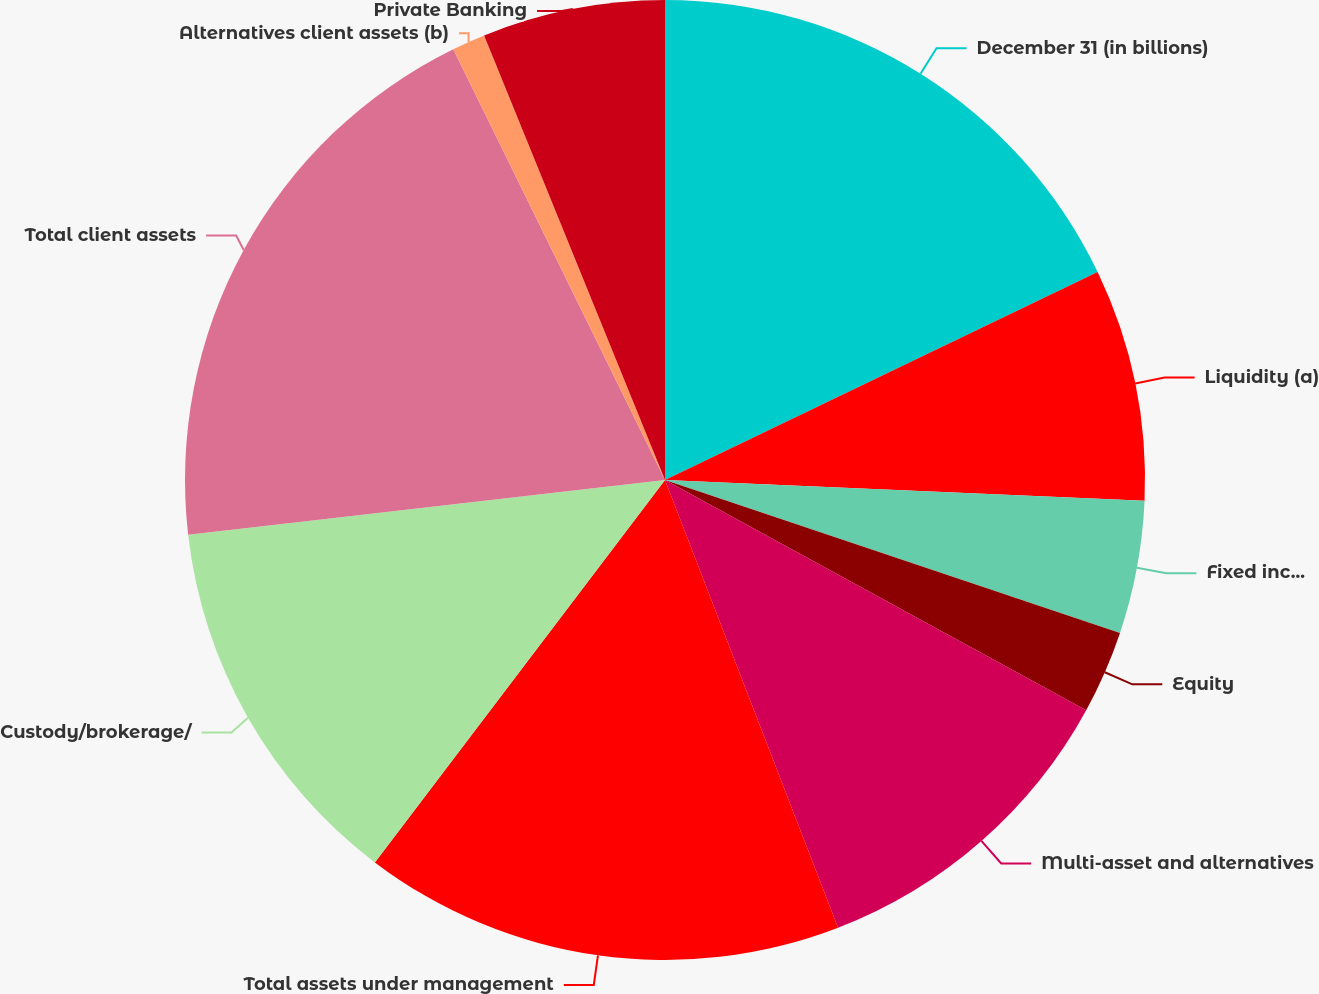Convert chart to OTSL. <chart><loc_0><loc_0><loc_500><loc_500><pie_chart><fcel>December 31 (in billions)<fcel>Liquidity (a)<fcel>Fixed income (a)<fcel>Equity<fcel>Multi-asset and alternatives<fcel>Total assets under management<fcel>Custody/brokerage/<fcel>Total client assets<fcel>Alternatives client assets (b)<fcel>Private Banking<nl><fcel>17.87%<fcel>7.82%<fcel>4.47%<fcel>2.8%<fcel>11.17%<fcel>16.2%<fcel>12.85%<fcel>19.55%<fcel>1.12%<fcel>6.15%<nl></chart> 